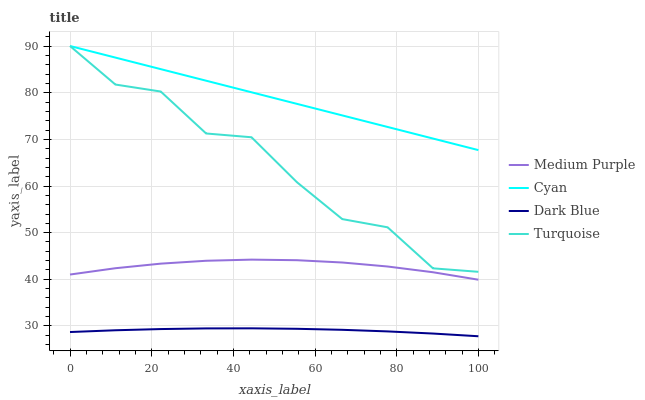Does Dark Blue have the minimum area under the curve?
Answer yes or no. Yes. Does Cyan have the maximum area under the curve?
Answer yes or no. Yes. Does Turquoise have the minimum area under the curve?
Answer yes or no. No. Does Turquoise have the maximum area under the curve?
Answer yes or no. No. Is Cyan the smoothest?
Answer yes or no. Yes. Is Turquoise the roughest?
Answer yes or no. Yes. Is Turquoise the smoothest?
Answer yes or no. No. Is Cyan the roughest?
Answer yes or no. No. Does Dark Blue have the lowest value?
Answer yes or no. Yes. Does Turquoise have the lowest value?
Answer yes or no. No. Does Turquoise have the highest value?
Answer yes or no. Yes. Does Dark Blue have the highest value?
Answer yes or no. No. Is Dark Blue less than Turquoise?
Answer yes or no. Yes. Is Turquoise greater than Dark Blue?
Answer yes or no. Yes. Does Cyan intersect Turquoise?
Answer yes or no. Yes. Is Cyan less than Turquoise?
Answer yes or no. No. Is Cyan greater than Turquoise?
Answer yes or no. No. Does Dark Blue intersect Turquoise?
Answer yes or no. No. 